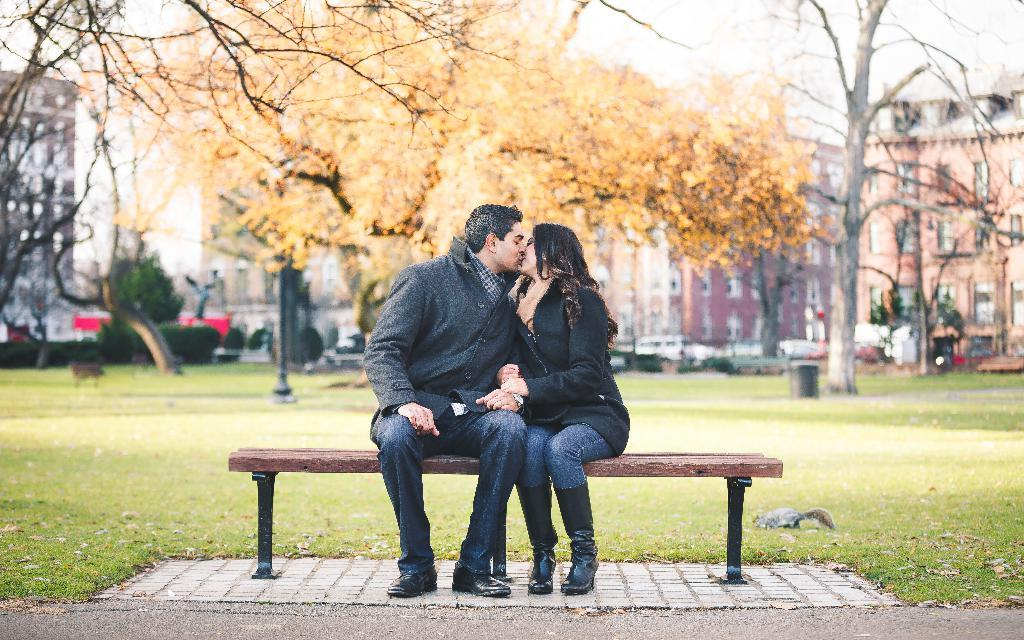How many people are sitting on the bench in the image? There are two persons sitting on a bench in the image. What are the two persons doing on the bench? The two persons are kissing each other. What can be seen in the background of the image? There is grass, a pole, trees, and buildings in the background. What type of tax is being discussed by the two persons on the bench? There is no indication in the image that the two persons are discussing any type of tax. 